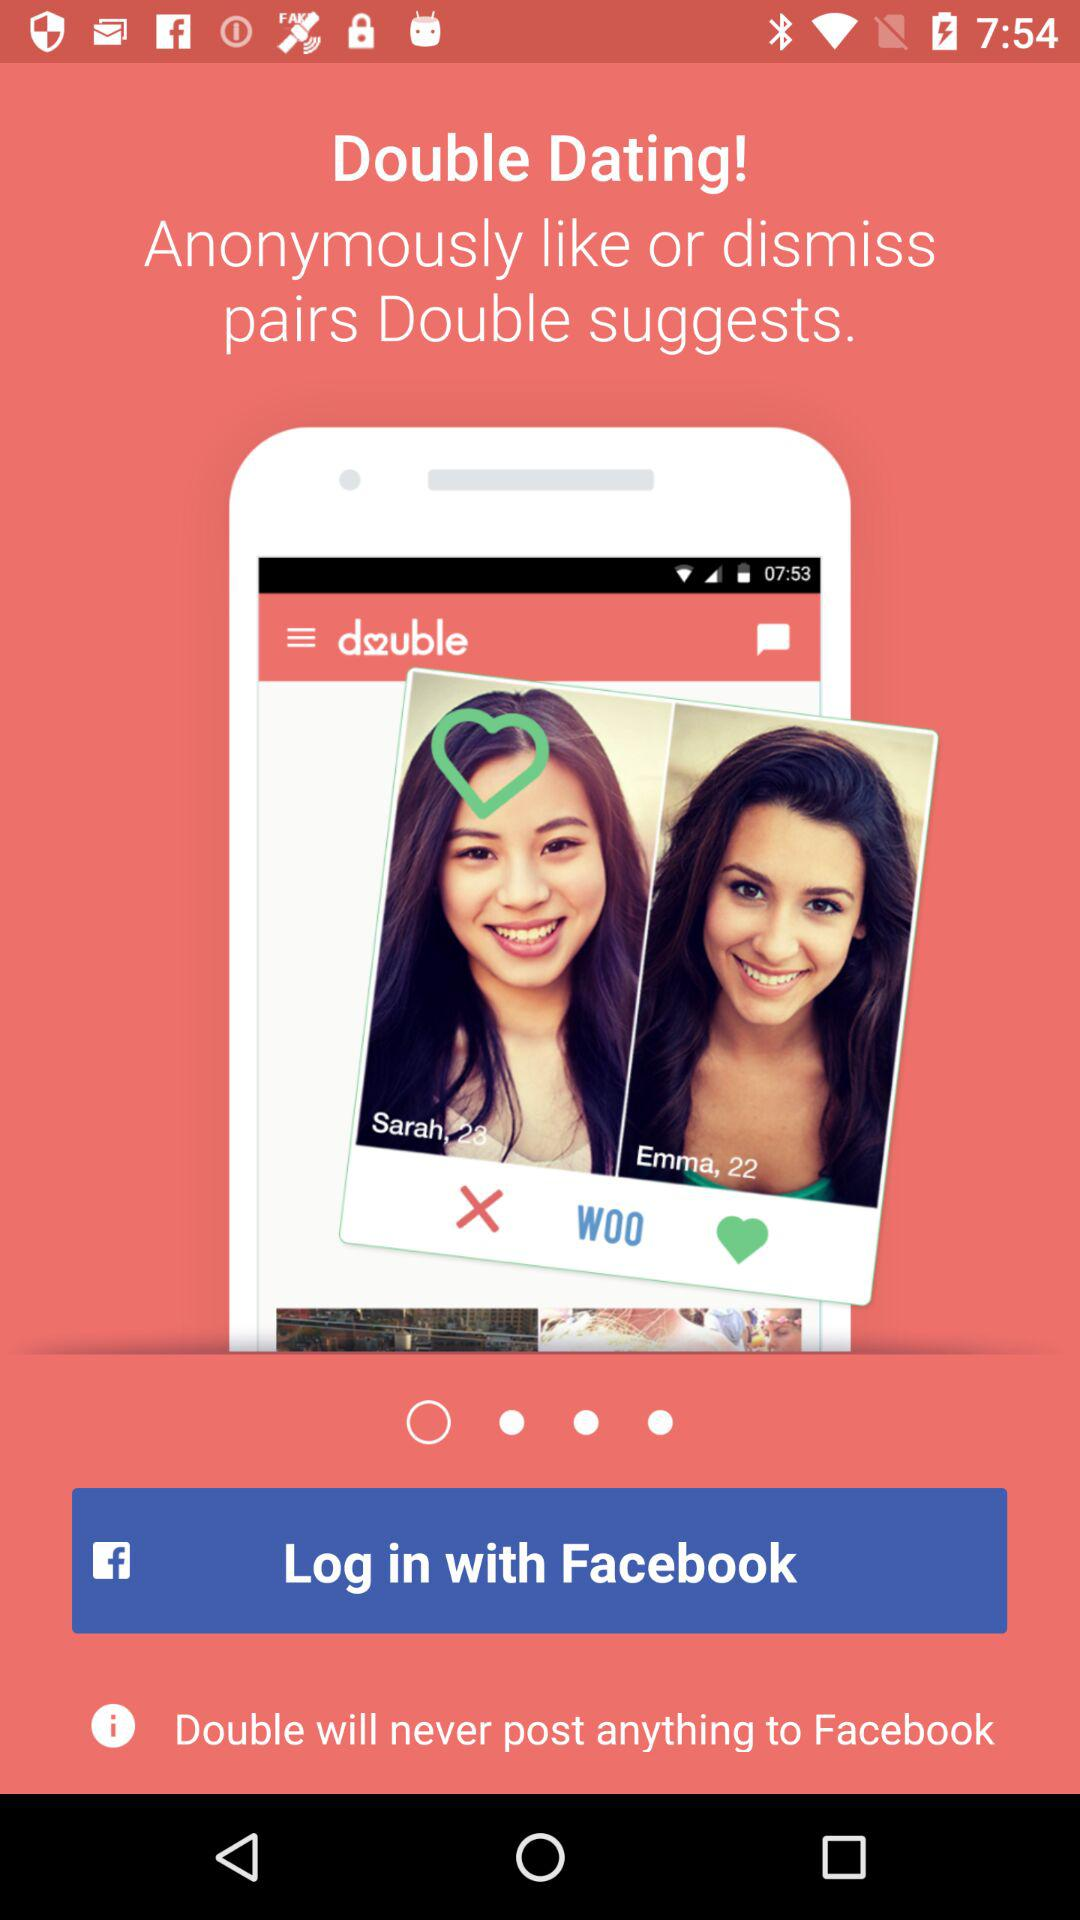What is the application name? The application name is "Double". 